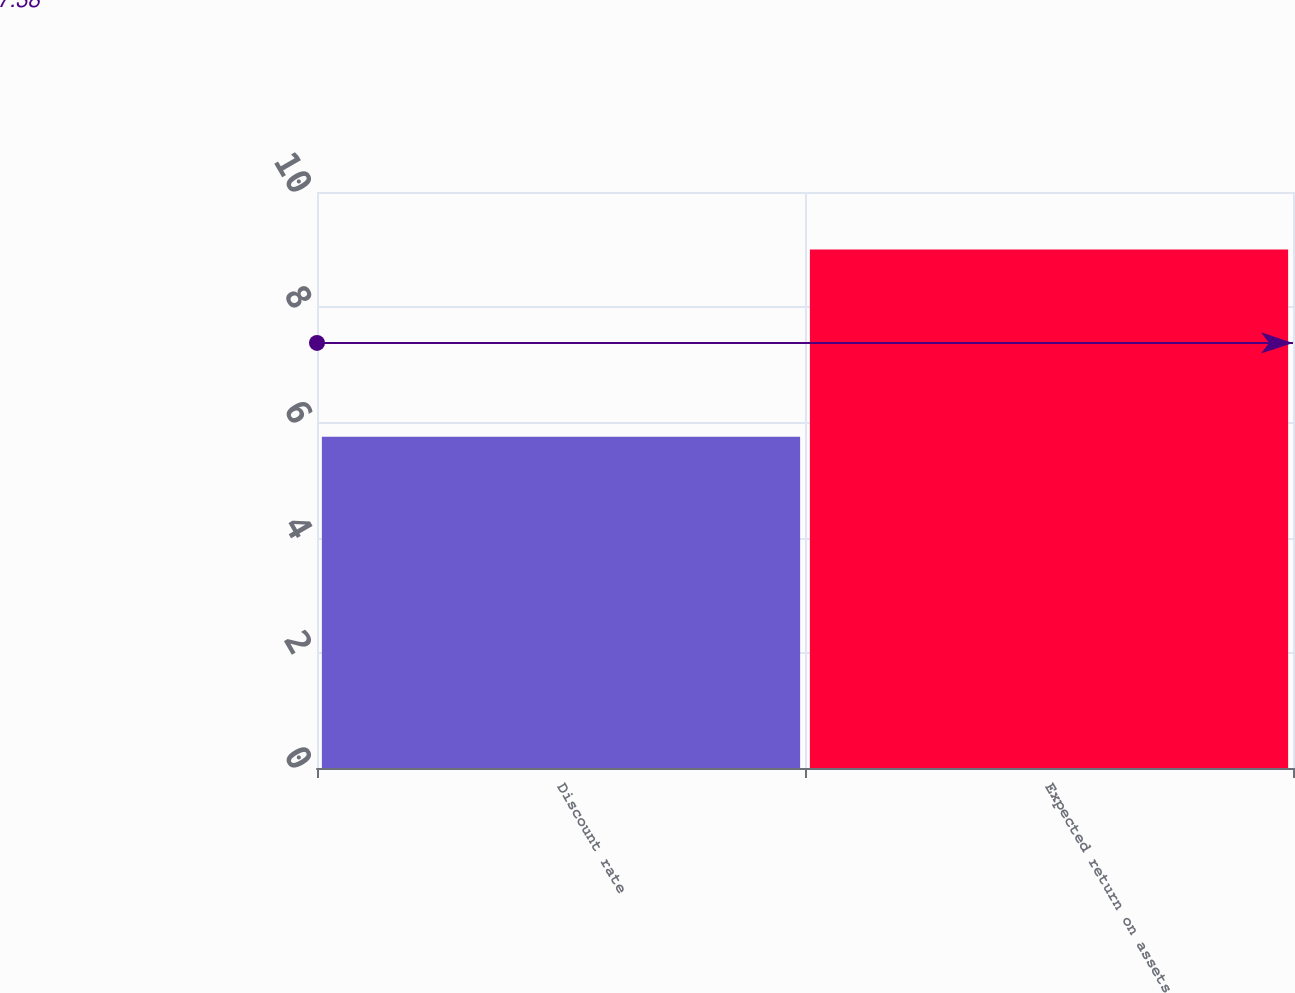Convert chart to OTSL. <chart><loc_0><loc_0><loc_500><loc_500><bar_chart><fcel>Discount rate<fcel>Expected return on assets<nl><fcel>5.75<fcel>9<nl></chart> 